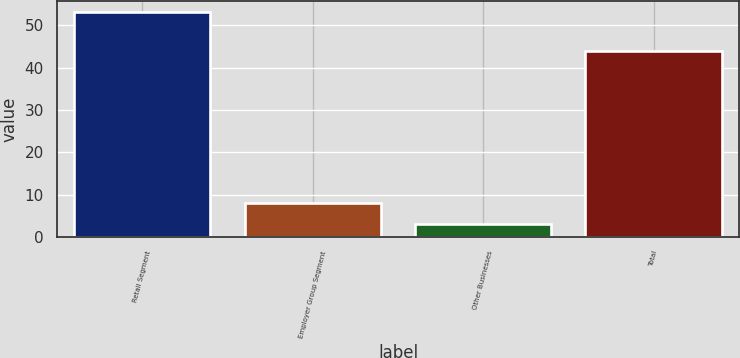Convert chart. <chart><loc_0><loc_0><loc_500><loc_500><bar_chart><fcel>Retail Segment<fcel>Employer Group Segment<fcel>Other Businesses<fcel>Total<nl><fcel>53<fcel>8<fcel>3<fcel>44<nl></chart> 